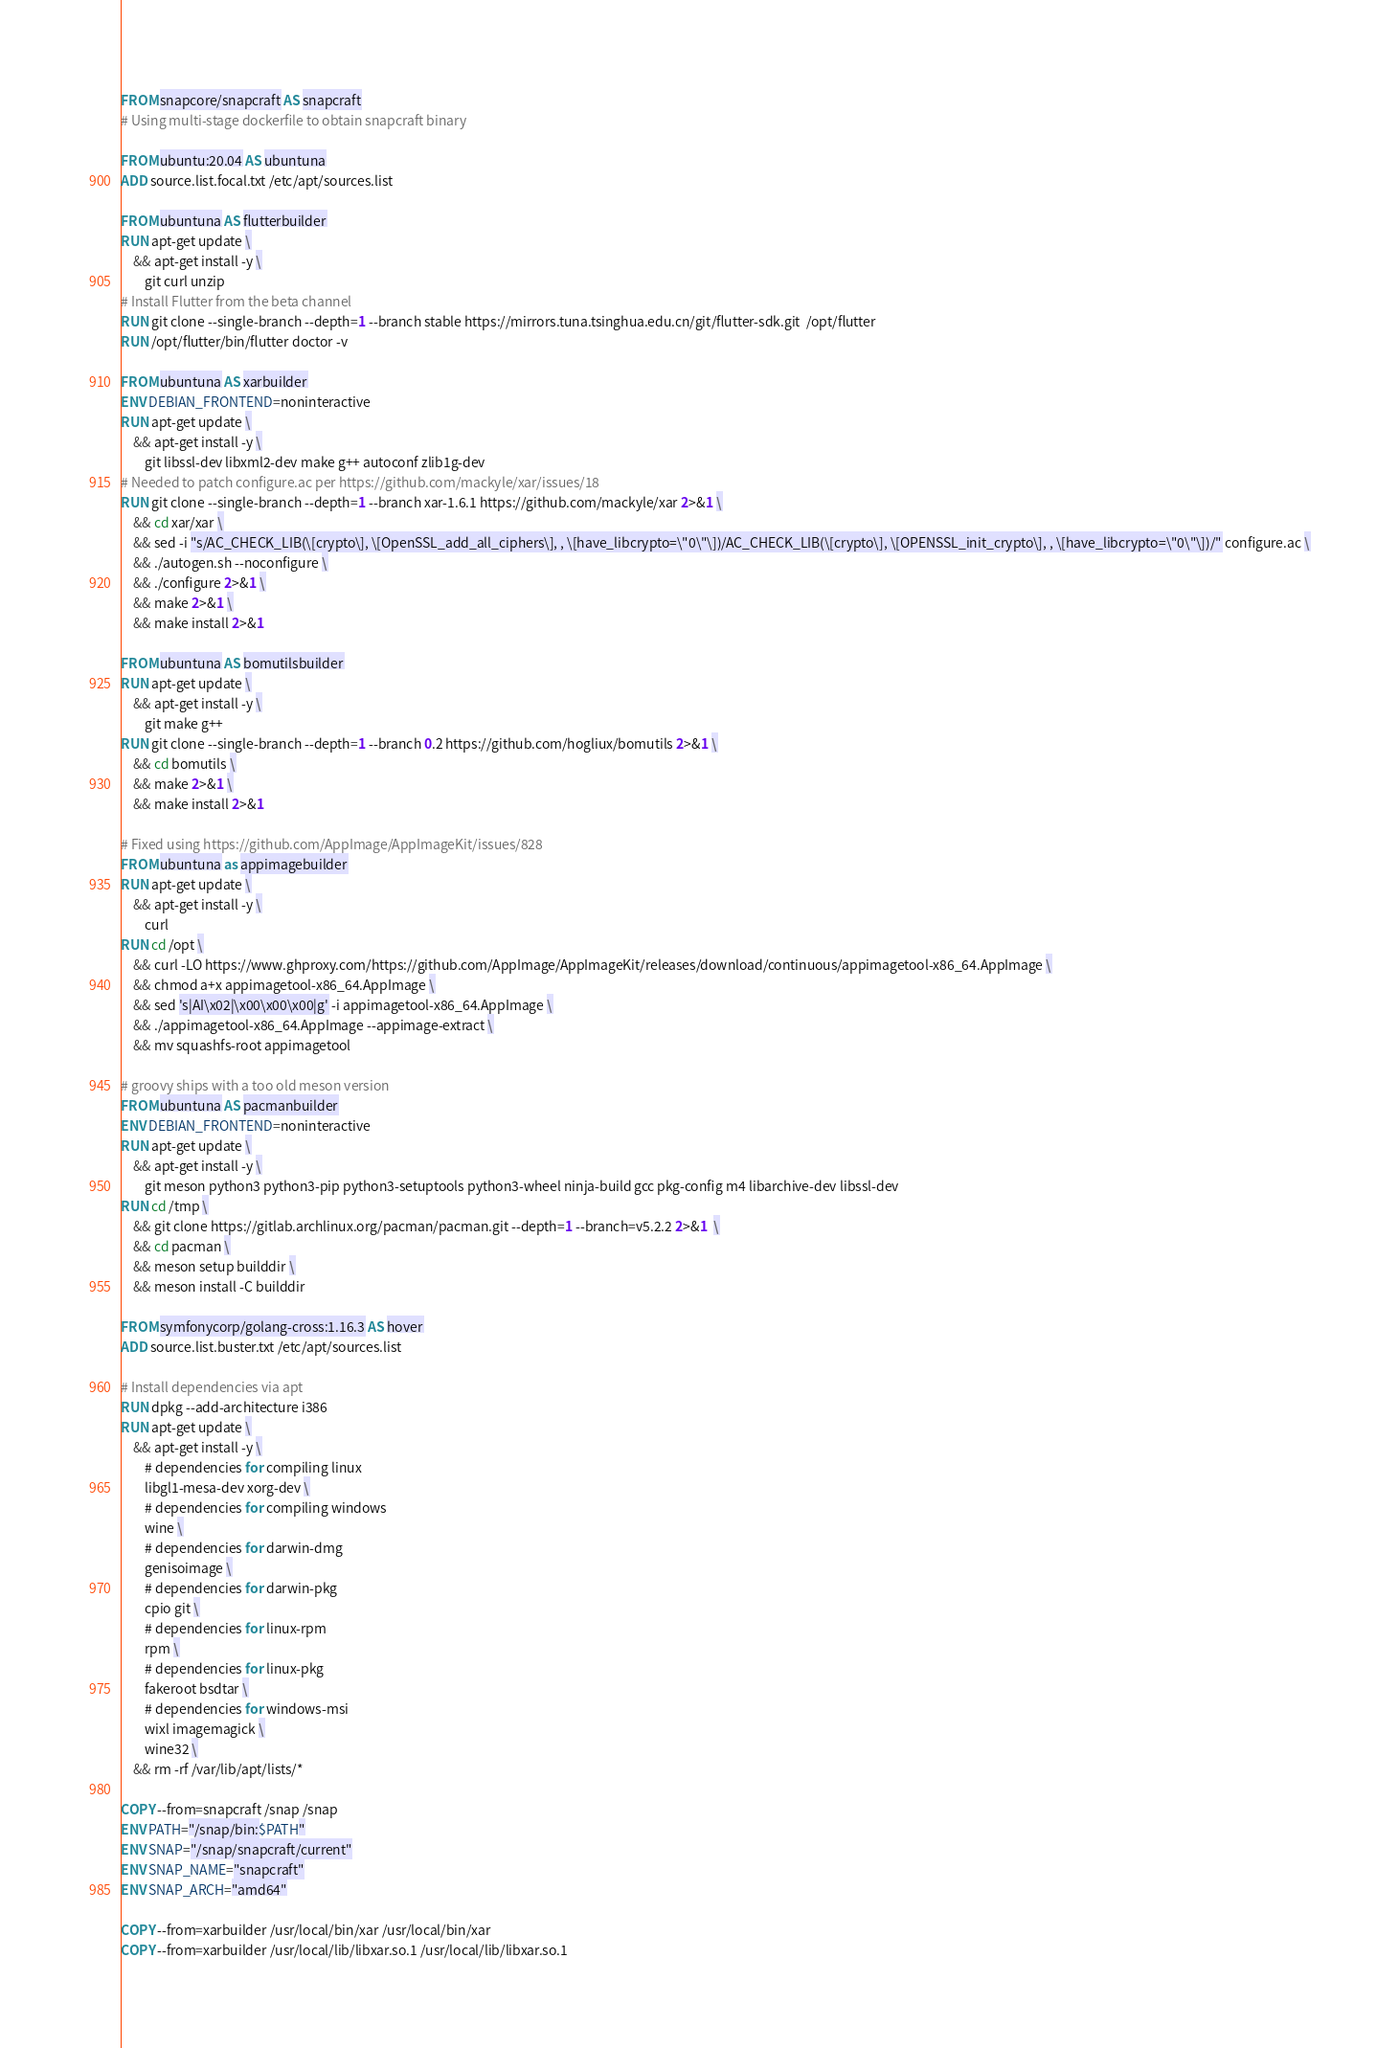<code> <loc_0><loc_0><loc_500><loc_500><_Dockerfile_>FROM snapcore/snapcraft AS snapcraft
# Using multi-stage dockerfile to obtain snapcraft binary

FROM ubuntu:20.04 AS ubuntuna
ADD source.list.focal.txt /etc/apt/sources.list

FROM ubuntuna AS flutterbuilder
RUN apt-get update \
    && apt-get install -y \
        git curl unzip
# Install Flutter from the beta channel
RUN git clone --single-branch --depth=1 --branch stable https://mirrors.tuna.tsinghua.edu.cn/git/flutter-sdk.git  /opt/flutter
RUN /opt/flutter/bin/flutter doctor -v

FROM ubuntuna AS xarbuilder
ENV DEBIAN_FRONTEND=noninteractive
RUN apt-get update \
	&& apt-get install -y \
		git libssl-dev libxml2-dev make g++ autoconf zlib1g-dev
# Needed to patch configure.ac per https://github.com/mackyle/xar/issues/18
RUN git clone --single-branch --depth=1 --branch xar-1.6.1 https://github.com/mackyle/xar 2>&1 \
	&& cd xar/xar \
	&& sed -i "s/AC_CHECK_LIB(\[crypto\], \[OpenSSL_add_all_ciphers\], , \[have_libcrypto=\"0\"\])/AC_CHECK_LIB(\[crypto\], \[OPENSSL_init_crypto\], , \[have_libcrypto=\"0\"\])/" configure.ac \
	&& ./autogen.sh --noconfigure \
	&& ./configure 2>&1 \
	&& make 2>&1 \
	&& make install 2>&1

FROM ubuntuna AS bomutilsbuilder
RUN apt-get update \
	&& apt-get install -y \
	    git make g++
RUN git clone --single-branch --depth=1 --branch 0.2 https://github.com/hogliux/bomutils 2>&1 \
	&& cd bomutils \
	&& make 2>&1 \
	&& make install 2>&1

# Fixed using https://github.com/AppImage/AppImageKit/issues/828
FROM ubuntuna as appimagebuilder
RUN apt-get update \
	&& apt-get install -y \
	    curl
RUN cd /opt \
	&& curl -LO https://www.ghproxy.com/https://github.com/AppImage/AppImageKit/releases/download/continuous/appimagetool-x86_64.AppImage \
	&& chmod a+x appimagetool-x86_64.AppImage \
	&& sed 's|AI\x02|\x00\x00\x00|g' -i appimagetool-x86_64.AppImage \
	&& ./appimagetool-x86_64.AppImage --appimage-extract \
	&& mv squashfs-root appimagetool

# groovy ships with a too old meson version
FROM ubuntuna AS pacmanbuilder
ENV DEBIAN_FRONTEND=noninteractive
RUN apt-get update \
    && apt-get install -y \
        git meson python3 python3-pip python3-setuptools python3-wheel ninja-build gcc pkg-config m4 libarchive-dev libssl-dev
RUN cd /tmp \
    && git clone https://gitlab.archlinux.org/pacman/pacman.git --depth=1 --branch=v5.2.2 2>&1  \
    && cd pacman \
    && meson setup builddir \
    && meson install -C builddir

FROM symfonycorp/golang-cross:1.16.3 AS hover
ADD source.list.buster.txt /etc/apt/sources.list

# Install dependencies via apt
RUN dpkg --add-architecture i386
RUN apt-get update \
	&& apt-get install -y \
	    # dependencies for compiling linux
		libgl1-mesa-dev xorg-dev \
		# dependencies for compiling windows
		wine \
		# dependencies for darwin-dmg
		genisoimage \
		# dependencies for darwin-pkg
		cpio git \
		# dependencies for linux-rpm
		rpm \
		# dependencies for linux-pkg
		fakeroot bsdtar \
		# dependencies for windows-msi
		wixl imagemagick \
        wine32 \
	&& rm -rf /var/lib/apt/lists/*

COPY --from=snapcraft /snap /snap
ENV PATH="/snap/bin:$PATH"
ENV SNAP="/snap/snapcraft/current"
ENV SNAP_NAME="snapcraft"
ENV SNAP_ARCH="amd64"

COPY --from=xarbuilder /usr/local/bin/xar /usr/local/bin/xar
COPY --from=xarbuilder /usr/local/lib/libxar.so.1 /usr/local/lib/libxar.so.1</code> 